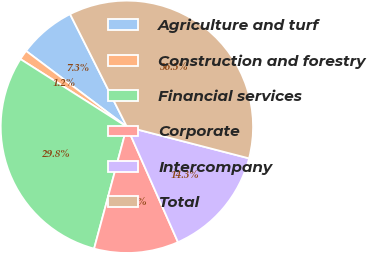<chart> <loc_0><loc_0><loc_500><loc_500><pie_chart><fcel>Agriculture and turf<fcel>Construction and forestry<fcel>Financial services<fcel>Corporate<fcel>Intercompany<fcel>Total<nl><fcel>7.3%<fcel>1.25%<fcel>29.83%<fcel>10.82%<fcel>14.34%<fcel>36.46%<nl></chart> 